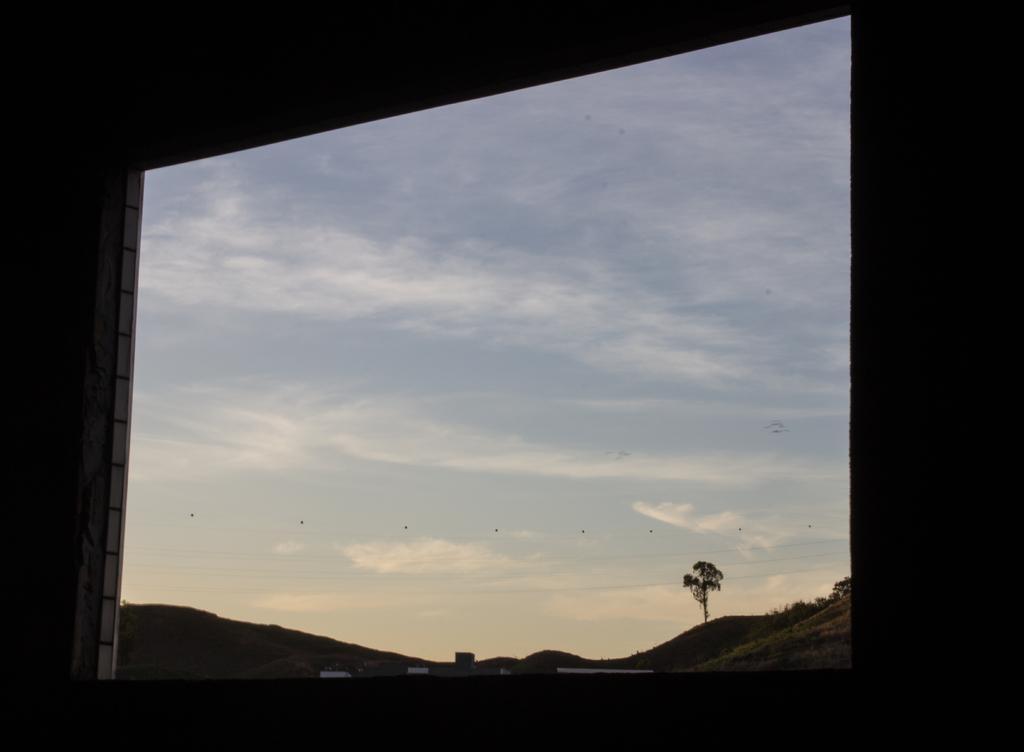In one or two sentences, can you explain what this image depicts? In this image we can see sky, clouds, tree from the window. 